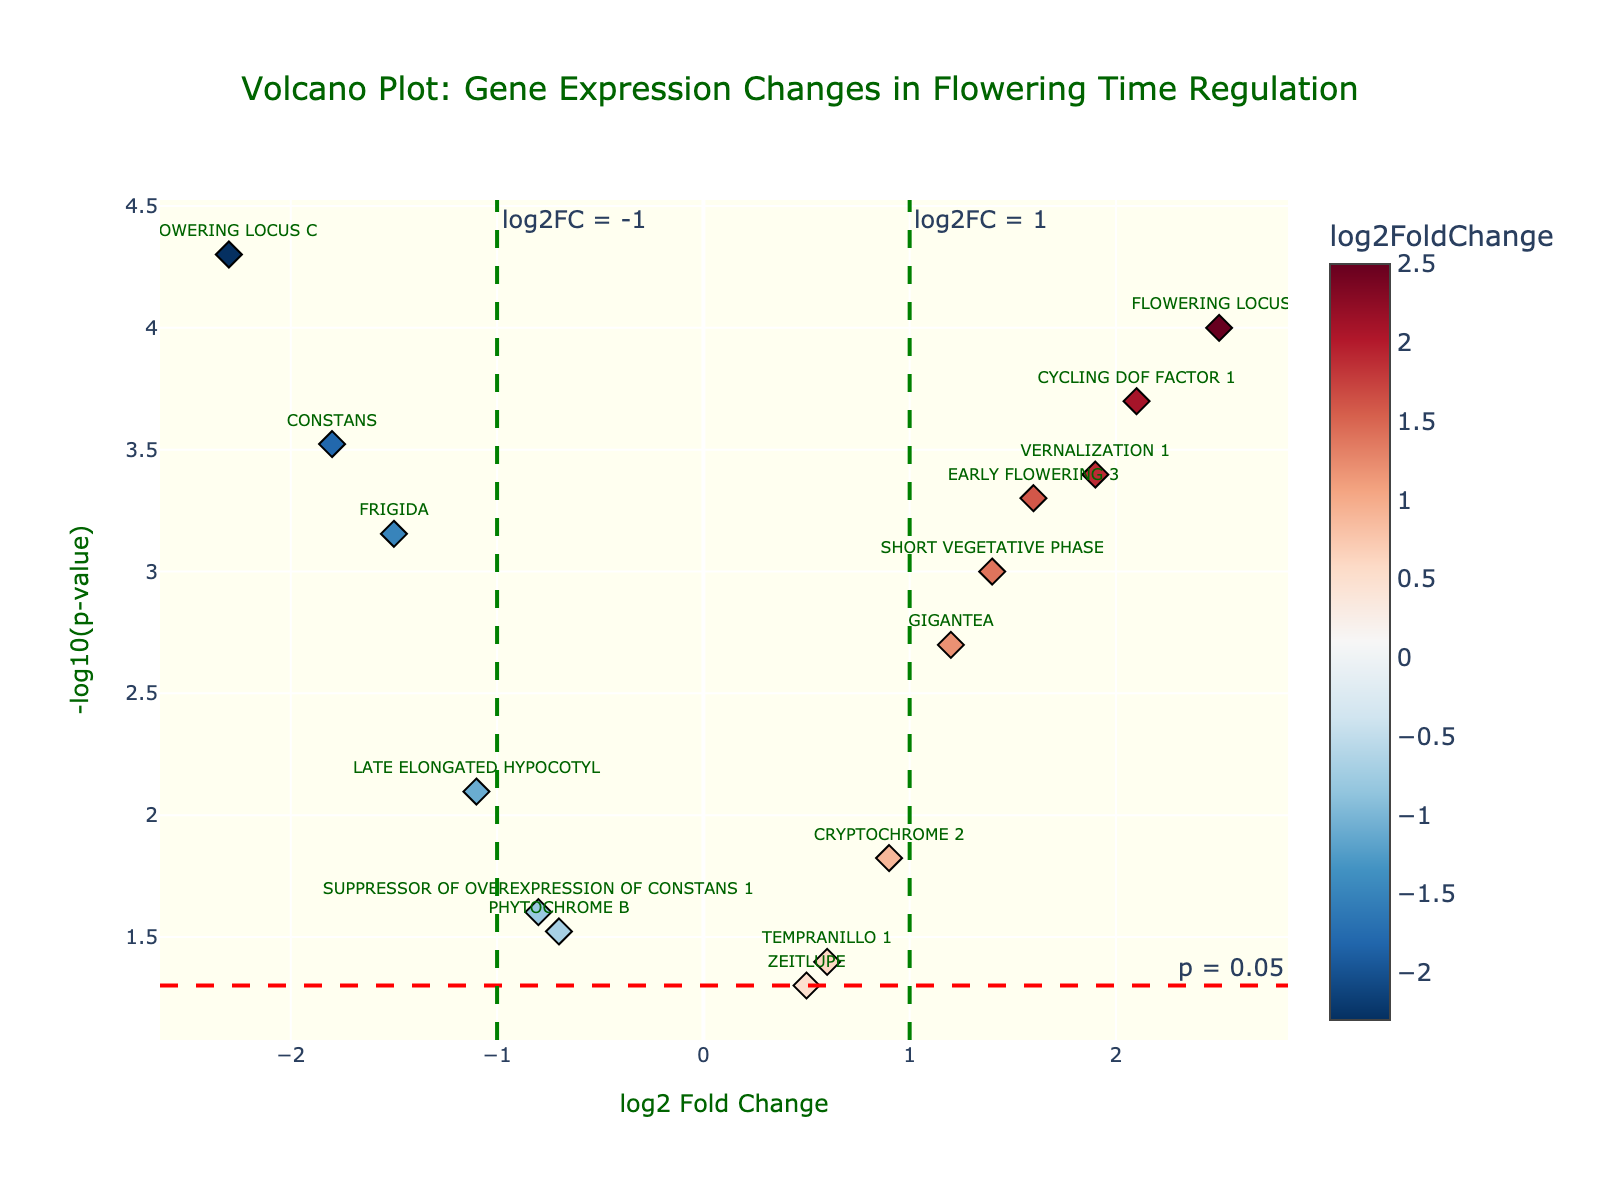How many genes are plotted in the figure? Count the number of unique points labeled by gene names in the volcano plot. There are 15 distinct gene names.
Answer: 15 Which gene has the highest log2 fold change? Identify the gene furthest to the right on the x-axis. "FLOWERING LOCUS T" has the highest log2 fold change at 2.5.
Answer: FLOWERING LOCUS T Which gene(s) fall below the significance threshold of p = 0.05? Look for genes above the red horizontal line indicating -log10(p-value) of 0.05. Genes above this line include "FLOWERING LOCUS T", "CONSTANS", "GIGANTEA", "CRYPTOCHROME 2", "EARLY FLOWERING 3", "LATE ELONGATED HYPOCOTYL", "CYCLING DOF FACTOR 1", "SUPPRESSOR OF OVEREXPRESSION OF CONSTANS 1", "FLOWERING LOCUS C", "SHORT VEGETATIVE PHASE", "VERNALIZATION 1", and "FRIGIDA".
Answer: FLOWERING LOCUS T, CONSTANS, GIGANTEA, CRYPTOCHROME 2, EARLY FLOWERING 3, LATE ELONGATED HYPOCOTYL, CYCLING DOF FACTOR 1, SUPPRESSOR OF OVEREXPRESSION OF CONSTANS 1, FLOWERING LOCUS C, SHORT VEGETATIVE PHASE, VERNALIZATION 1, FRIGIDA Which gene is closest to the origin (0,0) in the plot? Find the point that is nearest to zero on both the x- and y-axes. "ZEITLUPE" is closest to the origin with log2FoldChange of 0.5 and -log10(p-value) of 1.301.
Answer: ZEITLUPE Which gene has both significant p-value (p < 0.05) and a log2 fold change greater than 1? Identify genes above the red line (-log10(p-value) corresponding to p = 0.05) and to the right of the green vertical line at log2FC = 1. These genes include "FLOWERING LOCUS T", "CYCLING DOF FACTOR 1", "SHORT VEGETATIVE PHASE", and "VERNALIZATION 1".
Answer: FLOWERING LOCUS T, CYCLING DOF FACTOR 1, SHORT VEGETATIVE PHASE, VERNALIZATION 1 Which gene has the most negative log2 fold change? Find the gene furthest to the left on the x-axis. "FLOWERING LOCUS C" has the most negative log2 fold change at -2.3.
Answer: FLOWERING LOCUS C What's the range of log2 fold changes observed? Calculate the difference between the highest and lowest log2 fold changes. The highest is 2.5, and the lowest is -2.3. The range is 2.5 - (-2.3) = 4.8.
Answer: 4.8 Are there more genes with a positive or negative log2 fold change? Compare the number of points on the right (positive) and left (negative) of the vertical line at x = 0. There are 8 genes with a positive log2 fold change and 7 with a negative log2 fold change.
Answer: Positive Which gene with a positive log2 fold change has the lowest p-value? Among the genes with positive log2 fold change, find the one with the highest -log10(p-value). "FLOWERING LOCUS T" has the lowest p-value with -log10(p-value) of 4.
Answer: FLOWERING LOCUS T What are the log2 fold change and p-value for "CONSTANS"? Locate "CONSTANS" on the plot; its log2 fold change is -1.8, and its p-value corresponds to -log10(p-value) of 3.522. The back calculation of p-value is 10^-3.522.
Answer: log2 fold change: -1.8, p-value: 0.0003 